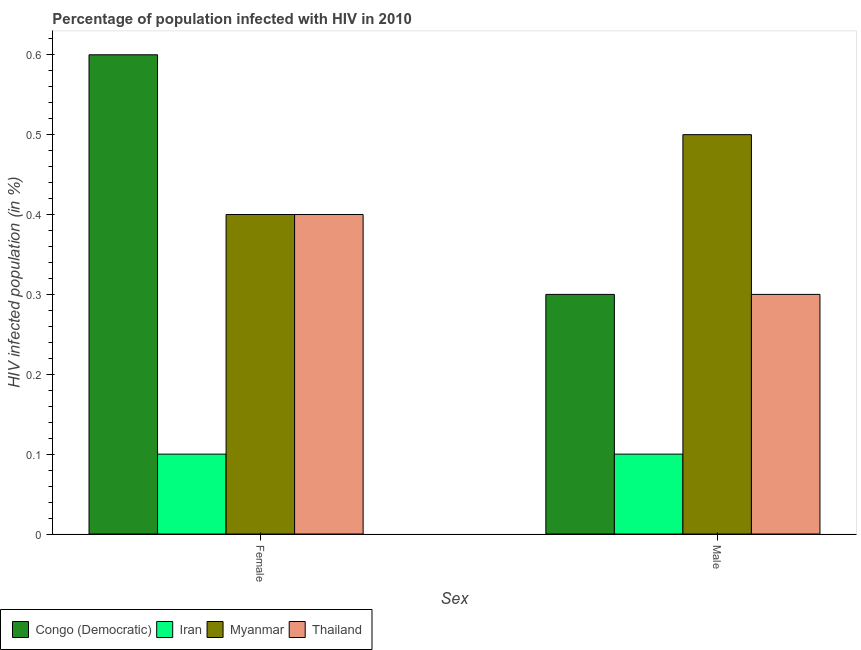How many different coloured bars are there?
Your answer should be very brief. 4. How many groups of bars are there?
Your answer should be very brief. 2. How many bars are there on the 1st tick from the left?
Offer a very short reply. 4. How many bars are there on the 1st tick from the right?
Ensure brevity in your answer.  4. Across all countries, what is the maximum percentage of males who are infected with hiv?
Ensure brevity in your answer.  0.5. In which country was the percentage of males who are infected with hiv maximum?
Give a very brief answer. Myanmar. In which country was the percentage of females who are infected with hiv minimum?
Make the answer very short. Iran. What is the difference between the percentage of males who are infected with hiv in Thailand and that in Congo (Democratic)?
Give a very brief answer. 0. What is the difference between the percentage of males who are infected with hiv in Iran and the percentage of females who are infected with hiv in Thailand?
Offer a very short reply. -0.3. What is the average percentage of females who are infected with hiv per country?
Make the answer very short. 0.38. What is the difference between the percentage of females who are infected with hiv and percentage of males who are infected with hiv in Congo (Democratic)?
Offer a very short reply. 0.3. What does the 2nd bar from the left in Female represents?
Offer a terse response. Iran. What does the 1st bar from the right in Male represents?
Offer a terse response. Thailand. How many bars are there?
Your answer should be very brief. 8. Are all the bars in the graph horizontal?
Your answer should be compact. No. Are the values on the major ticks of Y-axis written in scientific E-notation?
Offer a very short reply. No. Does the graph contain any zero values?
Make the answer very short. No. What is the title of the graph?
Ensure brevity in your answer.  Percentage of population infected with HIV in 2010. What is the label or title of the X-axis?
Your response must be concise. Sex. What is the label or title of the Y-axis?
Your answer should be compact. HIV infected population (in %). What is the HIV infected population (in %) of Congo (Democratic) in Female?
Make the answer very short. 0.6. What is the HIV infected population (in %) of Iran in Female?
Your answer should be compact. 0.1. What is the HIV infected population (in %) in Congo (Democratic) in Male?
Provide a short and direct response. 0.3. What is the HIV infected population (in %) in Iran in Male?
Your answer should be compact. 0.1. What is the HIV infected population (in %) in Myanmar in Male?
Your answer should be compact. 0.5. What is the HIV infected population (in %) of Thailand in Male?
Give a very brief answer. 0.3. Across all Sex, what is the maximum HIV infected population (in %) of Congo (Democratic)?
Keep it short and to the point. 0.6. Across all Sex, what is the maximum HIV infected population (in %) of Iran?
Give a very brief answer. 0.1. Across all Sex, what is the maximum HIV infected population (in %) in Thailand?
Your answer should be very brief. 0.4. Across all Sex, what is the minimum HIV infected population (in %) in Congo (Democratic)?
Provide a succinct answer. 0.3. Across all Sex, what is the minimum HIV infected population (in %) in Iran?
Keep it short and to the point. 0.1. Across all Sex, what is the minimum HIV infected population (in %) of Myanmar?
Provide a short and direct response. 0.4. Across all Sex, what is the minimum HIV infected population (in %) of Thailand?
Your response must be concise. 0.3. What is the total HIV infected population (in %) in Congo (Democratic) in the graph?
Give a very brief answer. 0.9. What is the total HIV infected population (in %) in Myanmar in the graph?
Offer a terse response. 0.9. What is the difference between the HIV infected population (in %) in Iran in Female and that in Male?
Ensure brevity in your answer.  0. What is the difference between the HIV infected population (in %) of Congo (Democratic) in Female and the HIV infected population (in %) of Myanmar in Male?
Your answer should be very brief. 0.1. What is the difference between the HIV infected population (in %) in Iran in Female and the HIV infected population (in %) in Myanmar in Male?
Ensure brevity in your answer.  -0.4. What is the difference between the HIV infected population (in %) of Iran in Female and the HIV infected population (in %) of Thailand in Male?
Give a very brief answer. -0.2. What is the difference between the HIV infected population (in %) in Myanmar in Female and the HIV infected population (in %) in Thailand in Male?
Offer a terse response. 0.1. What is the average HIV infected population (in %) in Congo (Democratic) per Sex?
Your answer should be compact. 0.45. What is the average HIV infected population (in %) in Myanmar per Sex?
Make the answer very short. 0.45. What is the average HIV infected population (in %) of Thailand per Sex?
Keep it short and to the point. 0.35. What is the difference between the HIV infected population (in %) of Congo (Democratic) and HIV infected population (in %) of Thailand in Female?
Provide a succinct answer. 0.2. What is the difference between the HIV infected population (in %) in Congo (Democratic) and HIV infected population (in %) in Myanmar in Male?
Offer a very short reply. -0.2. What is the difference between the HIV infected population (in %) in Congo (Democratic) and HIV infected population (in %) in Thailand in Male?
Ensure brevity in your answer.  0. What is the difference between the HIV infected population (in %) in Iran and HIV infected population (in %) in Myanmar in Male?
Your response must be concise. -0.4. What is the difference between the HIV infected population (in %) of Iran and HIV infected population (in %) of Thailand in Male?
Make the answer very short. -0.2. What is the ratio of the HIV infected population (in %) of Myanmar in Female to that in Male?
Keep it short and to the point. 0.8. What is the ratio of the HIV infected population (in %) of Thailand in Female to that in Male?
Offer a terse response. 1.33. What is the difference between the highest and the second highest HIV infected population (in %) in Iran?
Give a very brief answer. 0. What is the difference between the highest and the second highest HIV infected population (in %) in Thailand?
Provide a succinct answer. 0.1. What is the difference between the highest and the lowest HIV infected population (in %) of Iran?
Offer a terse response. 0. What is the difference between the highest and the lowest HIV infected population (in %) of Myanmar?
Provide a short and direct response. 0.1. What is the difference between the highest and the lowest HIV infected population (in %) in Thailand?
Ensure brevity in your answer.  0.1. 